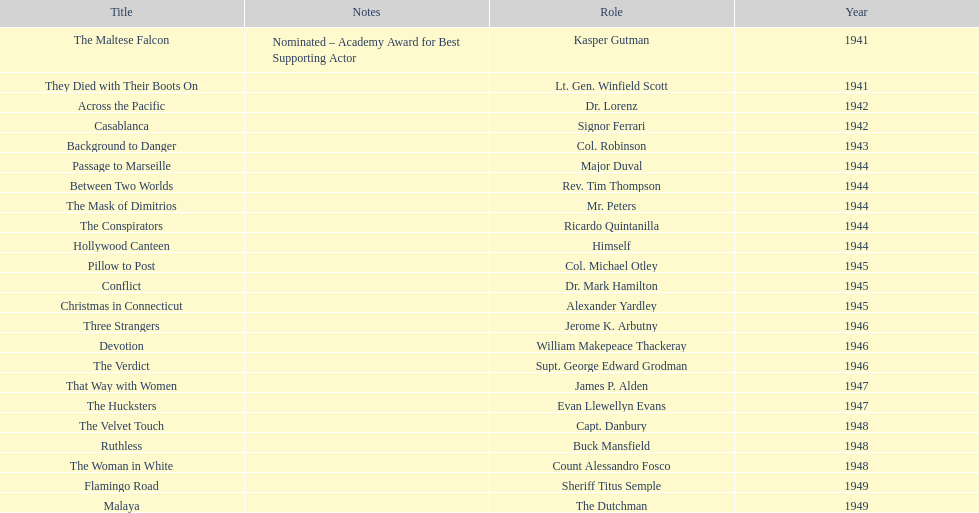What movies did greenstreet act for in 1946? Three Strangers, Devotion, The Verdict. 